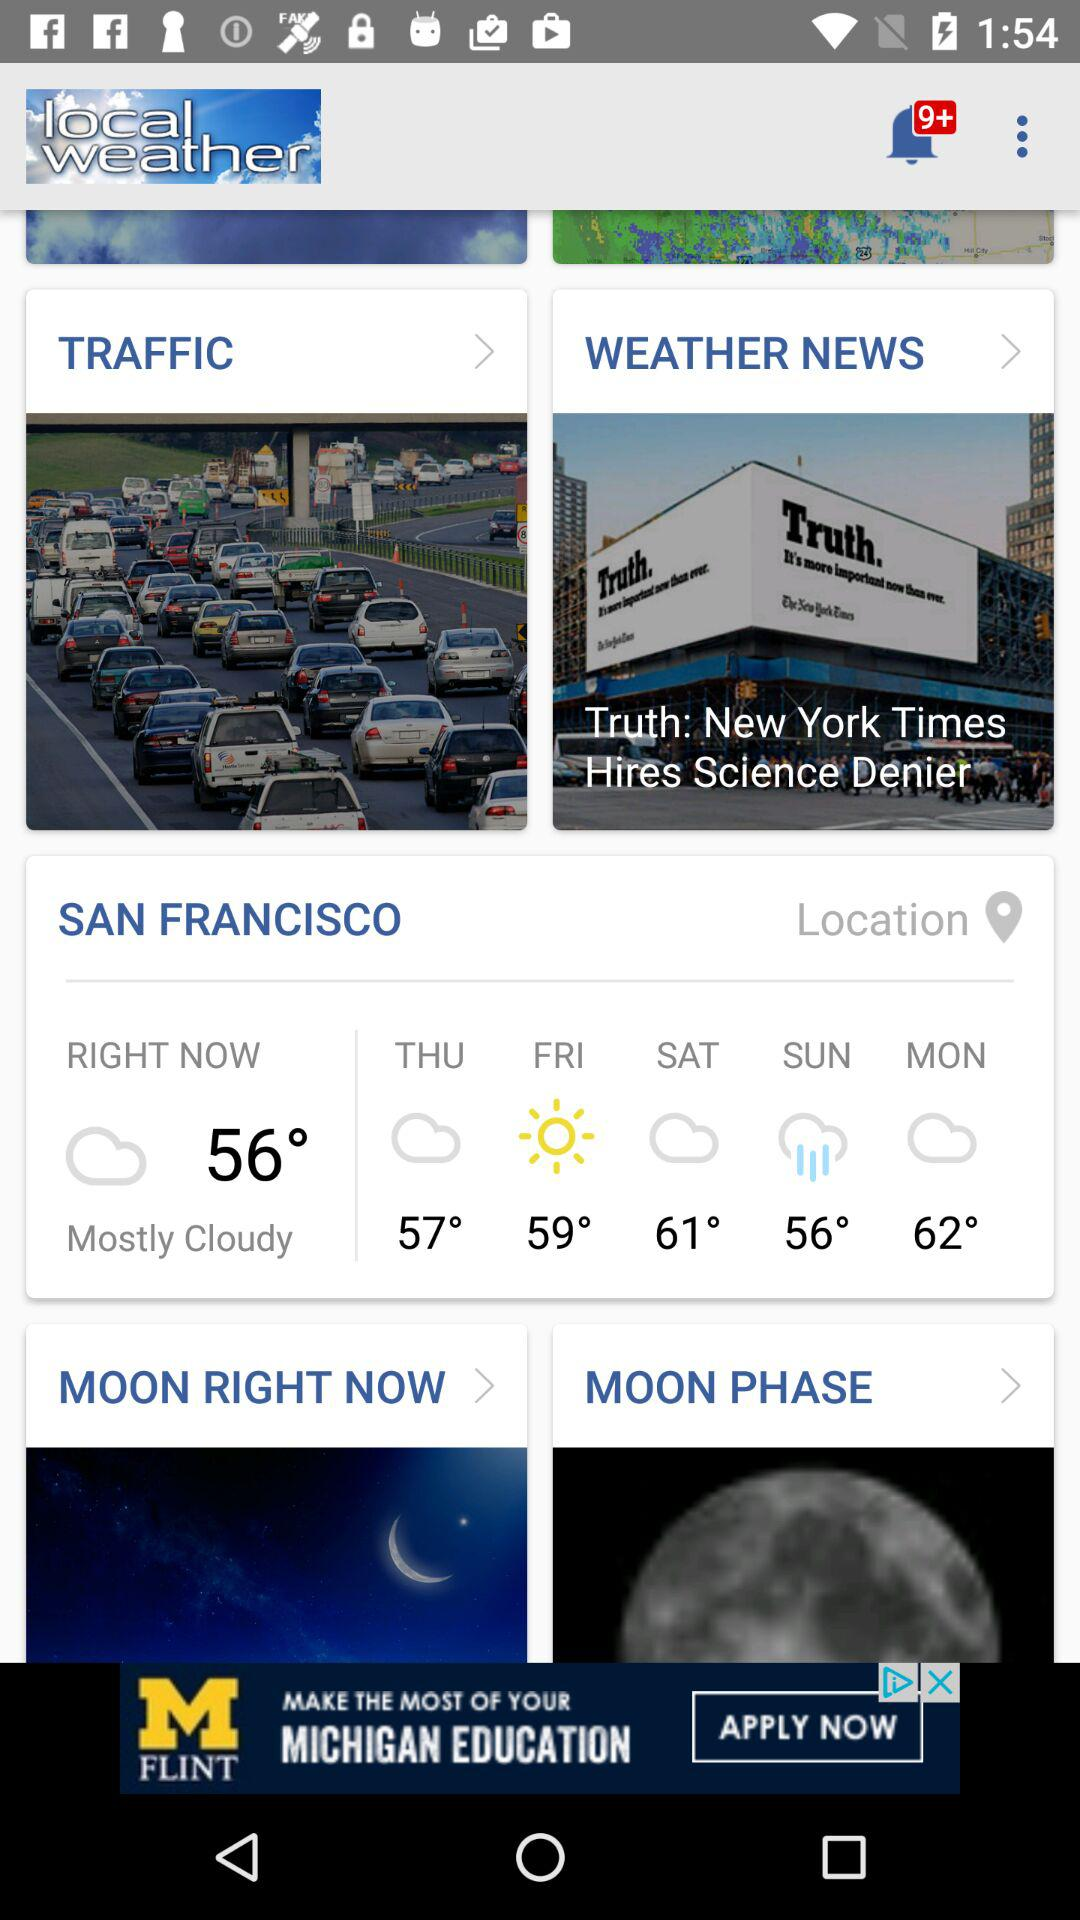What is the temperature right now? The temperature is 56°. 